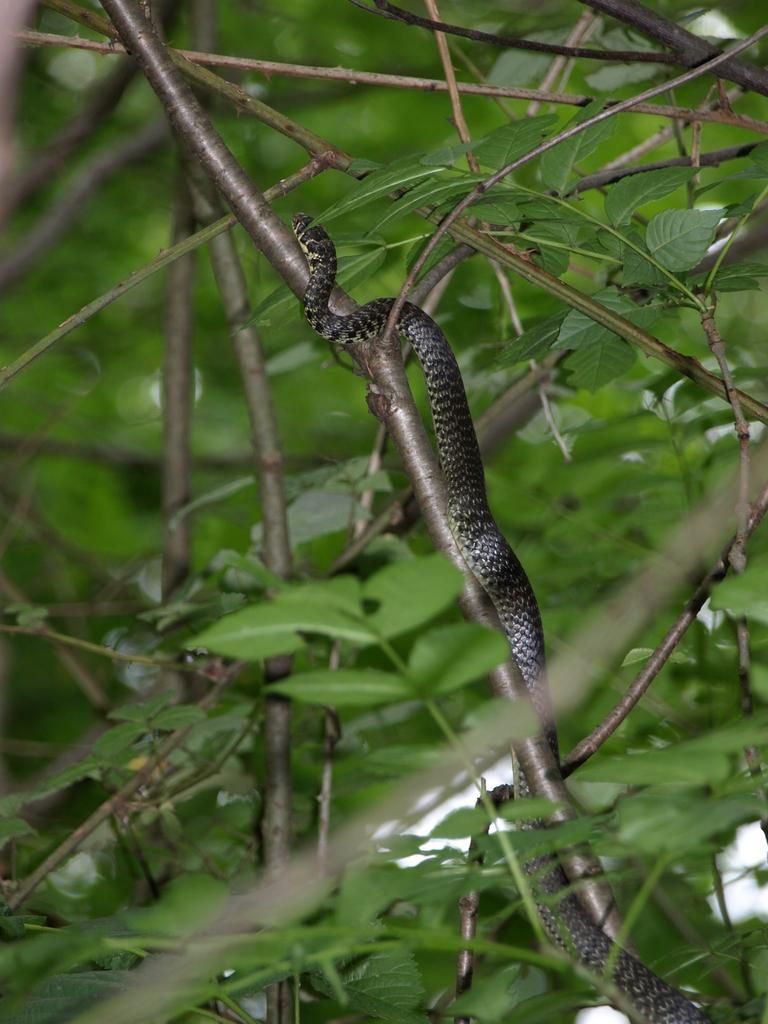Please provide a concise description of this image. In the foreground of this image, there is a snake on a stem around which, there are leaves and stems. 